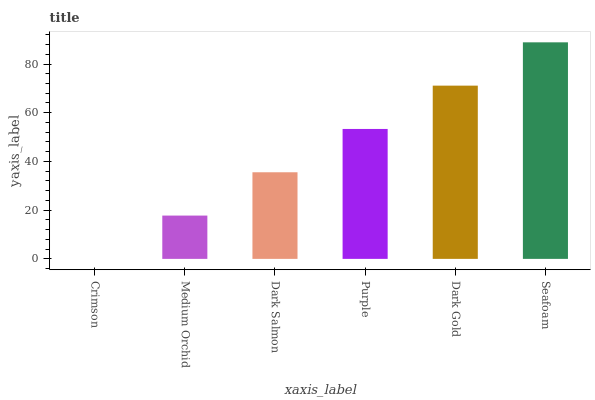Is Crimson the minimum?
Answer yes or no. Yes. Is Seafoam the maximum?
Answer yes or no. Yes. Is Medium Orchid the minimum?
Answer yes or no. No. Is Medium Orchid the maximum?
Answer yes or no. No. Is Medium Orchid greater than Crimson?
Answer yes or no. Yes. Is Crimson less than Medium Orchid?
Answer yes or no. Yes. Is Crimson greater than Medium Orchid?
Answer yes or no. No. Is Medium Orchid less than Crimson?
Answer yes or no. No. Is Purple the high median?
Answer yes or no. Yes. Is Dark Salmon the low median?
Answer yes or no. Yes. Is Crimson the high median?
Answer yes or no. No. Is Seafoam the low median?
Answer yes or no. No. 